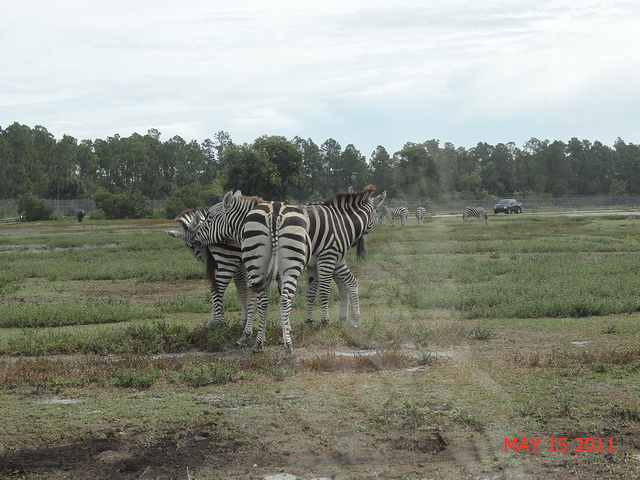What time of year does this photo suggest it was taken? The photo includes a date stamp of 'MAY 15 2011', which indicates it was taken in the spring. The greenery in the field and the mild weather suggested by the zebras' comfort outside also support this seasonal observation. 